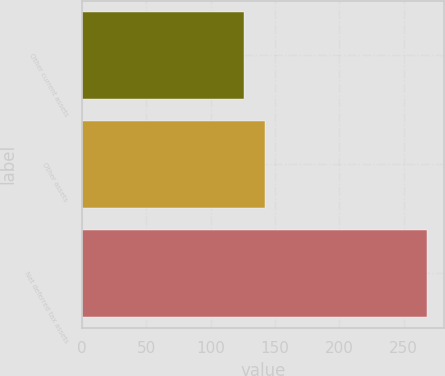Convert chart. <chart><loc_0><loc_0><loc_500><loc_500><bar_chart><fcel>Other current assets<fcel>Other assets<fcel>Net deferred tax assets<nl><fcel>126<fcel>142<fcel>268<nl></chart> 